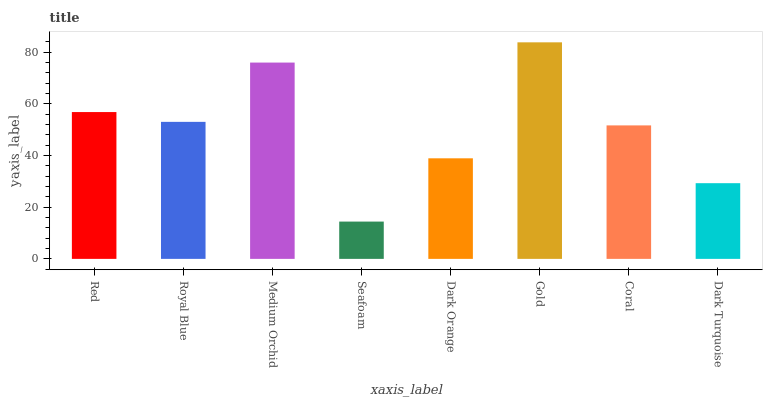Is Seafoam the minimum?
Answer yes or no. Yes. Is Gold the maximum?
Answer yes or no. Yes. Is Royal Blue the minimum?
Answer yes or no. No. Is Royal Blue the maximum?
Answer yes or no. No. Is Red greater than Royal Blue?
Answer yes or no. Yes. Is Royal Blue less than Red?
Answer yes or no. Yes. Is Royal Blue greater than Red?
Answer yes or no. No. Is Red less than Royal Blue?
Answer yes or no. No. Is Royal Blue the high median?
Answer yes or no. Yes. Is Coral the low median?
Answer yes or no. Yes. Is Gold the high median?
Answer yes or no. No. Is Dark Orange the low median?
Answer yes or no. No. 